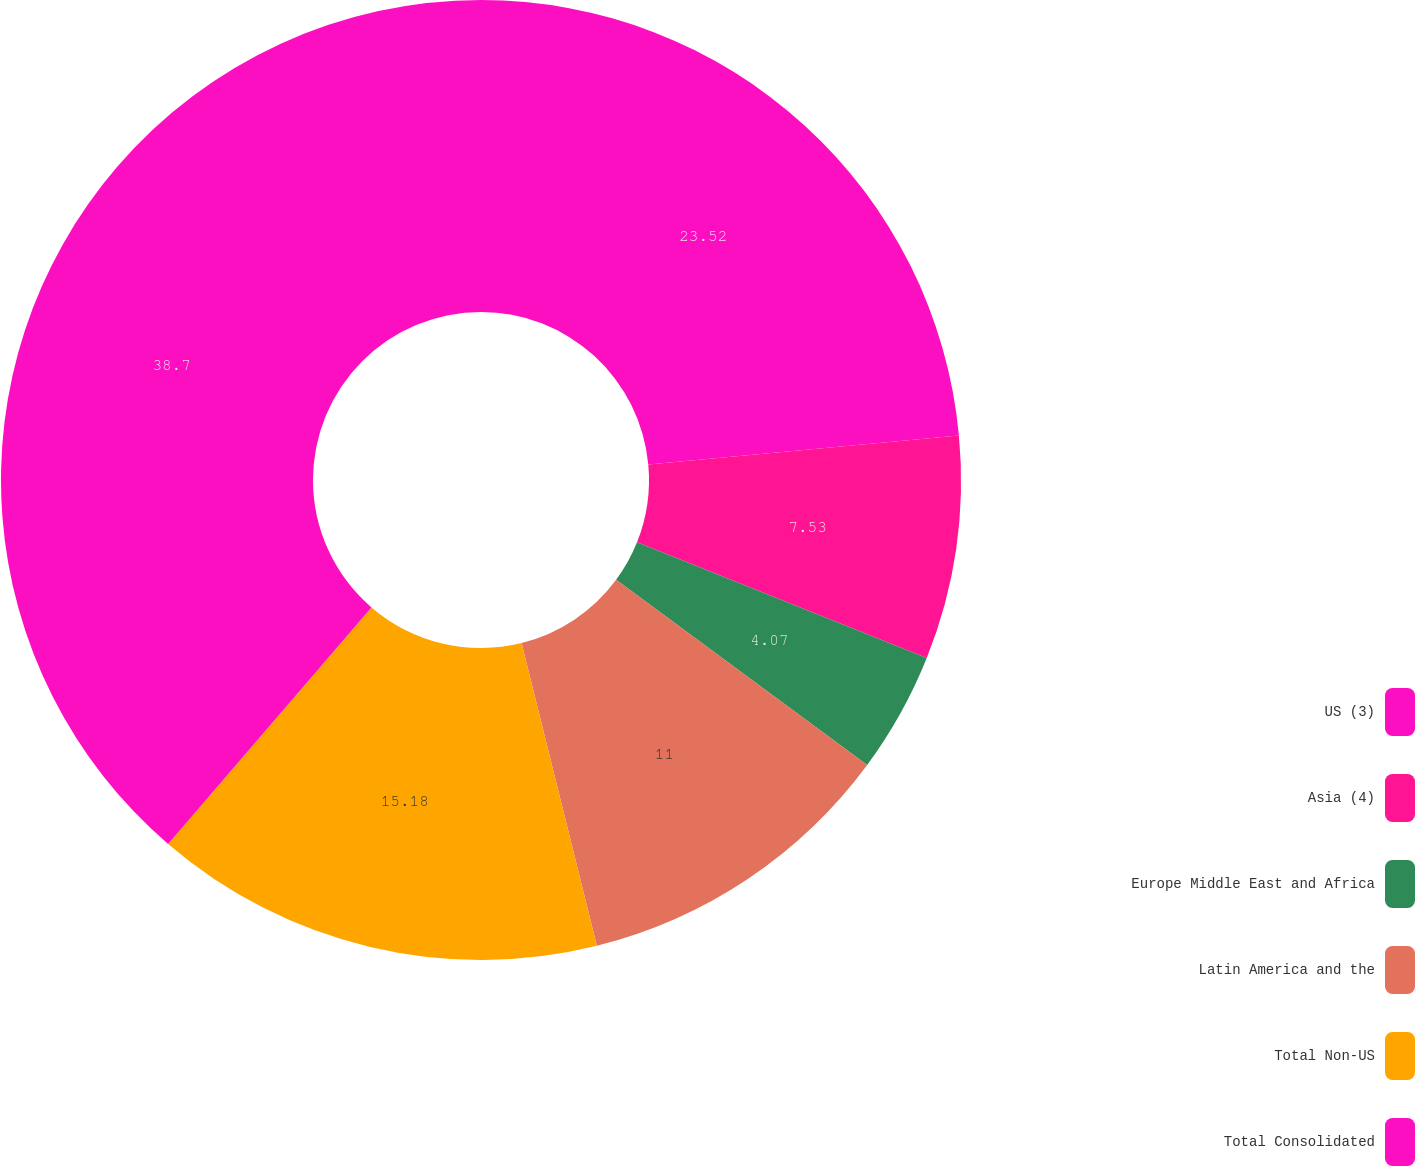Convert chart. <chart><loc_0><loc_0><loc_500><loc_500><pie_chart><fcel>US (3)<fcel>Asia (4)<fcel>Europe Middle East and Africa<fcel>Latin America and the<fcel>Total Non-US<fcel>Total Consolidated<nl><fcel>23.52%<fcel>7.53%<fcel>4.07%<fcel>11.0%<fcel>15.18%<fcel>38.7%<nl></chart> 